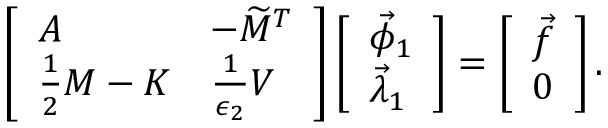Convert formula to latex. <formula><loc_0><loc_0><loc_500><loc_500>\begin{array} { r } { \left [ \begin{array} { l l } { A } & { - \widetilde { M } ^ { T } } \\ { \frac { 1 } { 2 } M - K } & { \frac { 1 } { \epsilon _ { 2 } } V } \end{array} \right ] \left [ \begin{array} { l } { \vec { \phi } _ { 1 } } \\ { \vec { \lambda } _ { 1 } } \end{array} \right ] = \left [ \begin{array} { l } { \vec { f } } \\ { 0 } \end{array} \right ] . } \end{array}</formula> 